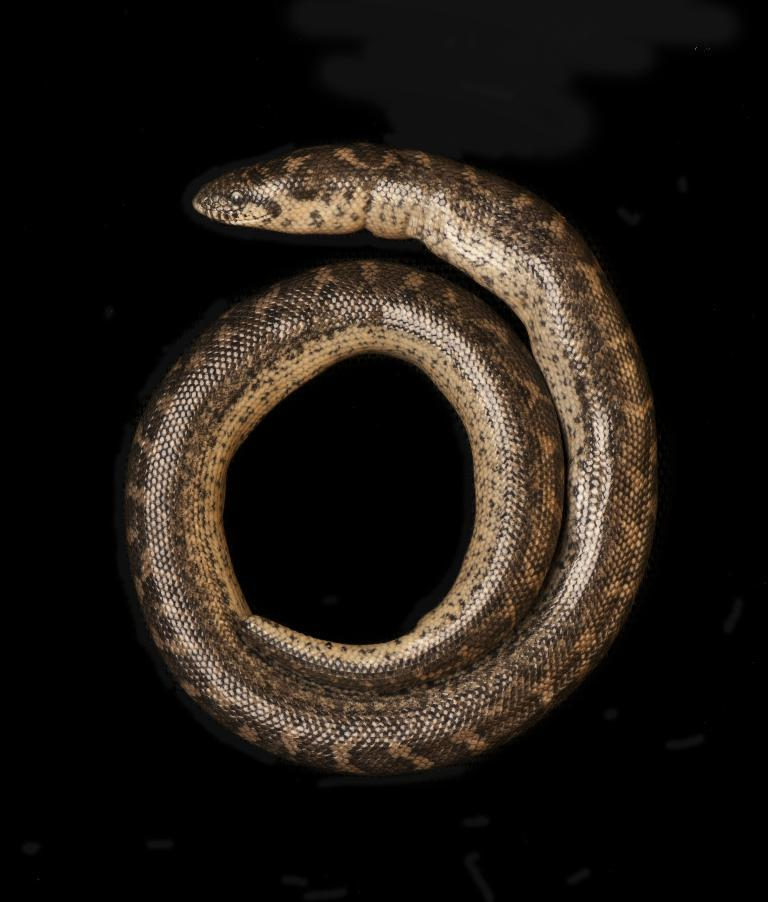What type of animal is present in the image? There is a snake in the image. What type of pizzas are being served in the image? There are no pizzas present in the image; it features a snake. What time of day is depicted in the image? The time of day cannot be determined from the image, as it only shows a snake. 